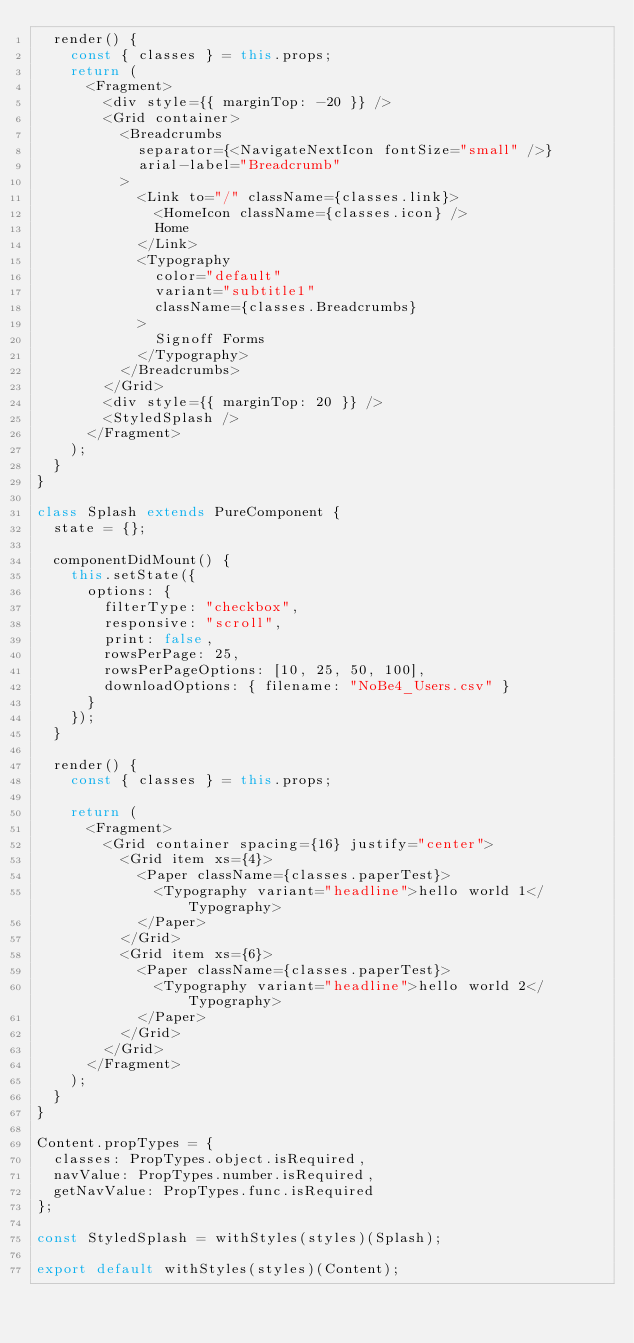Convert code to text. <code><loc_0><loc_0><loc_500><loc_500><_JavaScript_>  render() {
    const { classes } = this.props;
    return (
      <Fragment>
        <div style={{ marginTop: -20 }} />
        <Grid container>
          <Breadcrumbs
            separator={<NavigateNextIcon fontSize="small" />}
            arial-label="Breadcrumb"
          >
            <Link to="/" className={classes.link}>
              <HomeIcon className={classes.icon} />
              Home
            </Link>
            <Typography
              color="default"
              variant="subtitle1"
              className={classes.Breadcrumbs}
            >
              Signoff Forms
            </Typography>
          </Breadcrumbs>
        </Grid>
        <div style={{ marginTop: 20 }} />
        <StyledSplash />
      </Fragment>
    );
  }
}

class Splash extends PureComponent {
  state = {};

  componentDidMount() {
    this.setState({
      options: {
        filterType: "checkbox",
        responsive: "scroll",
        print: false,
        rowsPerPage: 25,
        rowsPerPageOptions: [10, 25, 50, 100],
        downloadOptions: { filename: "NoBe4_Users.csv" }
      }
    });
  }

  render() {
    const { classes } = this.props;

    return (
      <Fragment>
        <Grid container spacing={16} justify="center">
          <Grid item xs={4}>
            <Paper className={classes.paperTest}>
              <Typography variant="headline">hello world 1</Typography>
            </Paper>
          </Grid>
          <Grid item xs={6}>
            <Paper className={classes.paperTest}>
              <Typography variant="headline">hello world 2</Typography>
            </Paper>
          </Grid>
        </Grid>
      </Fragment>
    );
  }
}

Content.propTypes = {
  classes: PropTypes.object.isRequired,
  navValue: PropTypes.number.isRequired,
  getNavValue: PropTypes.func.isRequired
};

const StyledSplash = withStyles(styles)(Splash);

export default withStyles(styles)(Content);
</code> 